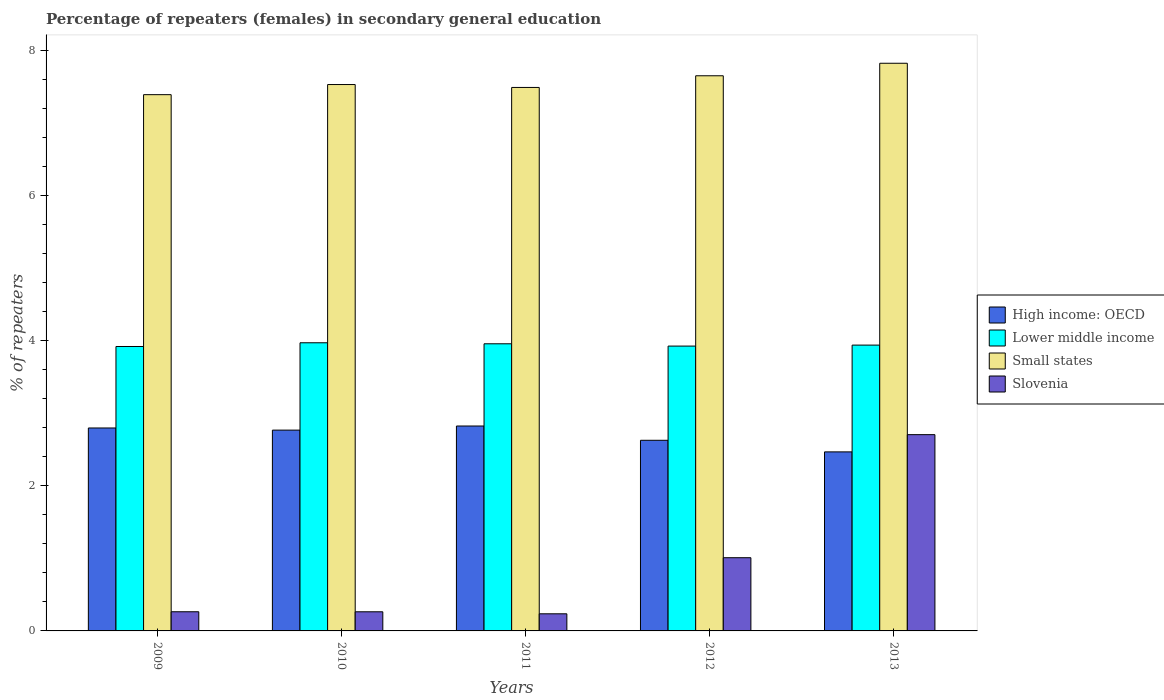How many different coloured bars are there?
Ensure brevity in your answer.  4. Are the number of bars per tick equal to the number of legend labels?
Ensure brevity in your answer.  Yes. How many bars are there on the 4th tick from the left?
Provide a succinct answer. 4. How many bars are there on the 2nd tick from the right?
Make the answer very short. 4. What is the label of the 5th group of bars from the left?
Your answer should be compact. 2013. In how many cases, is the number of bars for a given year not equal to the number of legend labels?
Ensure brevity in your answer.  0. What is the percentage of female repeaters in Small states in 2009?
Give a very brief answer. 7.39. Across all years, what is the maximum percentage of female repeaters in Slovenia?
Your response must be concise. 2.71. Across all years, what is the minimum percentage of female repeaters in Slovenia?
Give a very brief answer. 0.24. In which year was the percentage of female repeaters in High income: OECD maximum?
Keep it short and to the point. 2011. What is the total percentage of female repeaters in Slovenia in the graph?
Ensure brevity in your answer.  4.48. What is the difference between the percentage of female repeaters in Lower middle income in 2011 and that in 2012?
Provide a short and direct response. 0.03. What is the difference between the percentage of female repeaters in High income: OECD in 2011 and the percentage of female repeaters in Small states in 2009?
Your response must be concise. -4.57. What is the average percentage of female repeaters in Lower middle income per year?
Make the answer very short. 3.94. In the year 2011, what is the difference between the percentage of female repeaters in Slovenia and percentage of female repeaters in Lower middle income?
Your response must be concise. -3.72. What is the ratio of the percentage of female repeaters in Small states in 2009 to that in 2012?
Your answer should be very brief. 0.97. What is the difference between the highest and the second highest percentage of female repeaters in Slovenia?
Your response must be concise. 1.7. What is the difference between the highest and the lowest percentage of female repeaters in High income: OECD?
Your answer should be compact. 0.36. Is the sum of the percentage of female repeaters in Small states in 2011 and 2012 greater than the maximum percentage of female repeaters in Lower middle income across all years?
Make the answer very short. Yes. What does the 3rd bar from the left in 2013 represents?
Offer a very short reply. Small states. What does the 3rd bar from the right in 2013 represents?
Provide a succinct answer. Lower middle income. Is it the case that in every year, the sum of the percentage of female repeaters in High income: OECD and percentage of female repeaters in Slovenia is greater than the percentage of female repeaters in Lower middle income?
Give a very brief answer. No. How many bars are there?
Provide a succinct answer. 20. How many legend labels are there?
Ensure brevity in your answer.  4. What is the title of the graph?
Your answer should be very brief. Percentage of repeaters (females) in secondary general education. What is the label or title of the X-axis?
Give a very brief answer. Years. What is the label or title of the Y-axis?
Offer a terse response. % of repeaters. What is the % of repeaters in High income: OECD in 2009?
Keep it short and to the point. 2.8. What is the % of repeaters in Lower middle income in 2009?
Offer a terse response. 3.92. What is the % of repeaters of Small states in 2009?
Make the answer very short. 7.39. What is the % of repeaters in Slovenia in 2009?
Keep it short and to the point. 0.26. What is the % of repeaters of High income: OECD in 2010?
Offer a very short reply. 2.77. What is the % of repeaters in Lower middle income in 2010?
Provide a succinct answer. 3.97. What is the % of repeaters in Small states in 2010?
Provide a short and direct response. 7.53. What is the % of repeaters in Slovenia in 2010?
Provide a short and direct response. 0.26. What is the % of repeaters of High income: OECD in 2011?
Provide a short and direct response. 2.82. What is the % of repeaters of Lower middle income in 2011?
Offer a terse response. 3.96. What is the % of repeaters in Small states in 2011?
Make the answer very short. 7.49. What is the % of repeaters in Slovenia in 2011?
Offer a very short reply. 0.24. What is the % of repeaters of High income: OECD in 2012?
Your response must be concise. 2.63. What is the % of repeaters of Lower middle income in 2012?
Provide a succinct answer. 3.93. What is the % of repeaters of Small states in 2012?
Offer a very short reply. 7.65. What is the % of repeaters of Slovenia in 2012?
Your answer should be compact. 1.01. What is the % of repeaters in High income: OECD in 2013?
Provide a succinct answer. 2.47. What is the % of repeaters in Lower middle income in 2013?
Offer a very short reply. 3.94. What is the % of repeaters of Small states in 2013?
Your response must be concise. 7.83. What is the % of repeaters in Slovenia in 2013?
Your answer should be very brief. 2.71. Across all years, what is the maximum % of repeaters of High income: OECD?
Offer a terse response. 2.82. Across all years, what is the maximum % of repeaters in Lower middle income?
Offer a terse response. 3.97. Across all years, what is the maximum % of repeaters in Small states?
Your answer should be compact. 7.83. Across all years, what is the maximum % of repeaters in Slovenia?
Ensure brevity in your answer.  2.71. Across all years, what is the minimum % of repeaters in High income: OECD?
Your response must be concise. 2.47. Across all years, what is the minimum % of repeaters in Lower middle income?
Your answer should be very brief. 3.92. Across all years, what is the minimum % of repeaters in Small states?
Offer a terse response. 7.39. Across all years, what is the minimum % of repeaters in Slovenia?
Give a very brief answer. 0.24. What is the total % of repeaters in High income: OECD in the graph?
Provide a succinct answer. 13.49. What is the total % of repeaters in Lower middle income in the graph?
Your answer should be very brief. 19.72. What is the total % of repeaters of Small states in the graph?
Make the answer very short. 37.89. What is the total % of repeaters of Slovenia in the graph?
Offer a terse response. 4.48. What is the difference between the % of repeaters in High income: OECD in 2009 and that in 2010?
Your answer should be very brief. 0.03. What is the difference between the % of repeaters in Lower middle income in 2009 and that in 2010?
Offer a very short reply. -0.05. What is the difference between the % of repeaters of Small states in 2009 and that in 2010?
Make the answer very short. -0.14. What is the difference between the % of repeaters in High income: OECD in 2009 and that in 2011?
Your answer should be compact. -0.03. What is the difference between the % of repeaters of Lower middle income in 2009 and that in 2011?
Your answer should be compact. -0.04. What is the difference between the % of repeaters in Small states in 2009 and that in 2011?
Offer a very short reply. -0.1. What is the difference between the % of repeaters of Slovenia in 2009 and that in 2011?
Keep it short and to the point. 0.03. What is the difference between the % of repeaters of High income: OECD in 2009 and that in 2012?
Keep it short and to the point. 0.17. What is the difference between the % of repeaters in Lower middle income in 2009 and that in 2012?
Your response must be concise. -0.01. What is the difference between the % of repeaters in Small states in 2009 and that in 2012?
Make the answer very short. -0.26. What is the difference between the % of repeaters of Slovenia in 2009 and that in 2012?
Offer a terse response. -0.74. What is the difference between the % of repeaters in High income: OECD in 2009 and that in 2013?
Ensure brevity in your answer.  0.33. What is the difference between the % of repeaters in Lower middle income in 2009 and that in 2013?
Your answer should be very brief. -0.02. What is the difference between the % of repeaters of Small states in 2009 and that in 2013?
Give a very brief answer. -0.43. What is the difference between the % of repeaters in Slovenia in 2009 and that in 2013?
Your response must be concise. -2.44. What is the difference between the % of repeaters of High income: OECD in 2010 and that in 2011?
Provide a succinct answer. -0.06. What is the difference between the % of repeaters in Lower middle income in 2010 and that in 2011?
Offer a terse response. 0.01. What is the difference between the % of repeaters in Small states in 2010 and that in 2011?
Make the answer very short. 0.04. What is the difference between the % of repeaters of Slovenia in 2010 and that in 2011?
Provide a succinct answer. 0.03. What is the difference between the % of repeaters in High income: OECD in 2010 and that in 2012?
Your answer should be compact. 0.14. What is the difference between the % of repeaters of Lower middle income in 2010 and that in 2012?
Provide a short and direct response. 0.05. What is the difference between the % of repeaters in Small states in 2010 and that in 2012?
Provide a short and direct response. -0.12. What is the difference between the % of repeaters in Slovenia in 2010 and that in 2012?
Provide a short and direct response. -0.75. What is the difference between the % of repeaters of High income: OECD in 2010 and that in 2013?
Offer a very short reply. 0.3. What is the difference between the % of repeaters in Lower middle income in 2010 and that in 2013?
Make the answer very short. 0.03. What is the difference between the % of repeaters of Small states in 2010 and that in 2013?
Keep it short and to the point. -0.29. What is the difference between the % of repeaters in Slovenia in 2010 and that in 2013?
Offer a terse response. -2.44. What is the difference between the % of repeaters in High income: OECD in 2011 and that in 2012?
Keep it short and to the point. 0.2. What is the difference between the % of repeaters of Lower middle income in 2011 and that in 2012?
Provide a short and direct response. 0.03. What is the difference between the % of repeaters in Small states in 2011 and that in 2012?
Keep it short and to the point. -0.16. What is the difference between the % of repeaters in Slovenia in 2011 and that in 2012?
Offer a very short reply. -0.77. What is the difference between the % of repeaters of High income: OECD in 2011 and that in 2013?
Give a very brief answer. 0.36. What is the difference between the % of repeaters in Lower middle income in 2011 and that in 2013?
Keep it short and to the point. 0.02. What is the difference between the % of repeaters of Slovenia in 2011 and that in 2013?
Offer a terse response. -2.47. What is the difference between the % of repeaters in High income: OECD in 2012 and that in 2013?
Your response must be concise. 0.16. What is the difference between the % of repeaters of Lower middle income in 2012 and that in 2013?
Provide a succinct answer. -0.01. What is the difference between the % of repeaters in Small states in 2012 and that in 2013?
Your answer should be very brief. -0.17. What is the difference between the % of repeaters in Slovenia in 2012 and that in 2013?
Make the answer very short. -1.7. What is the difference between the % of repeaters of High income: OECD in 2009 and the % of repeaters of Lower middle income in 2010?
Provide a short and direct response. -1.17. What is the difference between the % of repeaters in High income: OECD in 2009 and the % of repeaters in Small states in 2010?
Ensure brevity in your answer.  -4.73. What is the difference between the % of repeaters of High income: OECD in 2009 and the % of repeaters of Slovenia in 2010?
Your response must be concise. 2.53. What is the difference between the % of repeaters of Lower middle income in 2009 and the % of repeaters of Small states in 2010?
Offer a terse response. -3.61. What is the difference between the % of repeaters in Lower middle income in 2009 and the % of repeaters in Slovenia in 2010?
Your response must be concise. 3.66. What is the difference between the % of repeaters in Small states in 2009 and the % of repeaters in Slovenia in 2010?
Your response must be concise. 7.13. What is the difference between the % of repeaters of High income: OECD in 2009 and the % of repeaters of Lower middle income in 2011?
Make the answer very short. -1.16. What is the difference between the % of repeaters of High income: OECD in 2009 and the % of repeaters of Small states in 2011?
Your response must be concise. -4.69. What is the difference between the % of repeaters of High income: OECD in 2009 and the % of repeaters of Slovenia in 2011?
Ensure brevity in your answer.  2.56. What is the difference between the % of repeaters of Lower middle income in 2009 and the % of repeaters of Small states in 2011?
Your response must be concise. -3.57. What is the difference between the % of repeaters of Lower middle income in 2009 and the % of repeaters of Slovenia in 2011?
Keep it short and to the point. 3.68. What is the difference between the % of repeaters in Small states in 2009 and the % of repeaters in Slovenia in 2011?
Ensure brevity in your answer.  7.16. What is the difference between the % of repeaters of High income: OECD in 2009 and the % of repeaters of Lower middle income in 2012?
Provide a short and direct response. -1.13. What is the difference between the % of repeaters in High income: OECD in 2009 and the % of repeaters in Small states in 2012?
Your answer should be very brief. -4.86. What is the difference between the % of repeaters of High income: OECD in 2009 and the % of repeaters of Slovenia in 2012?
Give a very brief answer. 1.79. What is the difference between the % of repeaters in Lower middle income in 2009 and the % of repeaters in Small states in 2012?
Give a very brief answer. -3.73. What is the difference between the % of repeaters of Lower middle income in 2009 and the % of repeaters of Slovenia in 2012?
Offer a terse response. 2.91. What is the difference between the % of repeaters in Small states in 2009 and the % of repeaters in Slovenia in 2012?
Give a very brief answer. 6.38. What is the difference between the % of repeaters of High income: OECD in 2009 and the % of repeaters of Lower middle income in 2013?
Ensure brevity in your answer.  -1.14. What is the difference between the % of repeaters in High income: OECD in 2009 and the % of repeaters in Small states in 2013?
Your response must be concise. -5.03. What is the difference between the % of repeaters of High income: OECD in 2009 and the % of repeaters of Slovenia in 2013?
Your answer should be very brief. 0.09. What is the difference between the % of repeaters of Lower middle income in 2009 and the % of repeaters of Small states in 2013?
Ensure brevity in your answer.  -3.9. What is the difference between the % of repeaters of Lower middle income in 2009 and the % of repeaters of Slovenia in 2013?
Provide a succinct answer. 1.22. What is the difference between the % of repeaters in Small states in 2009 and the % of repeaters in Slovenia in 2013?
Offer a very short reply. 4.69. What is the difference between the % of repeaters of High income: OECD in 2010 and the % of repeaters of Lower middle income in 2011?
Provide a succinct answer. -1.19. What is the difference between the % of repeaters in High income: OECD in 2010 and the % of repeaters in Small states in 2011?
Your response must be concise. -4.72. What is the difference between the % of repeaters in High income: OECD in 2010 and the % of repeaters in Slovenia in 2011?
Keep it short and to the point. 2.53. What is the difference between the % of repeaters in Lower middle income in 2010 and the % of repeaters in Small states in 2011?
Offer a terse response. -3.52. What is the difference between the % of repeaters of Lower middle income in 2010 and the % of repeaters of Slovenia in 2011?
Provide a succinct answer. 3.74. What is the difference between the % of repeaters of Small states in 2010 and the % of repeaters of Slovenia in 2011?
Your response must be concise. 7.3. What is the difference between the % of repeaters of High income: OECD in 2010 and the % of repeaters of Lower middle income in 2012?
Your answer should be compact. -1.16. What is the difference between the % of repeaters of High income: OECD in 2010 and the % of repeaters of Small states in 2012?
Make the answer very short. -4.88. What is the difference between the % of repeaters in High income: OECD in 2010 and the % of repeaters in Slovenia in 2012?
Offer a terse response. 1.76. What is the difference between the % of repeaters of Lower middle income in 2010 and the % of repeaters of Small states in 2012?
Give a very brief answer. -3.68. What is the difference between the % of repeaters of Lower middle income in 2010 and the % of repeaters of Slovenia in 2012?
Your answer should be very brief. 2.96. What is the difference between the % of repeaters of Small states in 2010 and the % of repeaters of Slovenia in 2012?
Offer a terse response. 6.52. What is the difference between the % of repeaters in High income: OECD in 2010 and the % of repeaters in Lower middle income in 2013?
Offer a very short reply. -1.17. What is the difference between the % of repeaters of High income: OECD in 2010 and the % of repeaters of Small states in 2013?
Your answer should be compact. -5.06. What is the difference between the % of repeaters in High income: OECD in 2010 and the % of repeaters in Slovenia in 2013?
Offer a very short reply. 0.06. What is the difference between the % of repeaters of Lower middle income in 2010 and the % of repeaters of Small states in 2013?
Provide a short and direct response. -3.85. What is the difference between the % of repeaters of Lower middle income in 2010 and the % of repeaters of Slovenia in 2013?
Offer a very short reply. 1.27. What is the difference between the % of repeaters in Small states in 2010 and the % of repeaters in Slovenia in 2013?
Give a very brief answer. 4.83. What is the difference between the % of repeaters of High income: OECD in 2011 and the % of repeaters of Lower middle income in 2012?
Your response must be concise. -1.1. What is the difference between the % of repeaters of High income: OECD in 2011 and the % of repeaters of Small states in 2012?
Give a very brief answer. -4.83. What is the difference between the % of repeaters of High income: OECD in 2011 and the % of repeaters of Slovenia in 2012?
Provide a short and direct response. 1.82. What is the difference between the % of repeaters in Lower middle income in 2011 and the % of repeaters in Small states in 2012?
Provide a short and direct response. -3.69. What is the difference between the % of repeaters of Lower middle income in 2011 and the % of repeaters of Slovenia in 2012?
Your answer should be very brief. 2.95. What is the difference between the % of repeaters in Small states in 2011 and the % of repeaters in Slovenia in 2012?
Make the answer very short. 6.48. What is the difference between the % of repeaters of High income: OECD in 2011 and the % of repeaters of Lower middle income in 2013?
Offer a terse response. -1.12. What is the difference between the % of repeaters of High income: OECD in 2011 and the % of repeaters of Small states in 2013?
Your answer should be very brief. -5. What is the difference between the % of repeaters in High income: OECD in 2011 and the % of repeaters in Slovenia in 2013?
Your answer should be very brief. 0.12. What is the difference between the % of repeaters of Lower middle income in 2011 and the % of repeaters of Small states in 2013?
Provide a short and direct response. -3.87. What is the difference between the % of repeaters in Lower middle income in 2011 and the % of repeaters in Slovenia in 2013?
Keep it short and to the point. 1.25. What is the difference between the % of repeaters of Small states in 2011 and the % of repeaters of Slovenia in 2013?
Provide a short and direct response. 4.79. What is the difference between the % of repeaters in High income: OECD in 2012 and the % of repeaters in Lower middle income in 2013?
Your answer should be very brief. -1.31. What is the difference between the % of repeaters in High income: OECD in 2012 and the % of repeaters in Small states in 2013?
Give a very brief answer. -5.2. What is the difference between the % of repeaters of High income: OECD in 2012 and the % of repeaters of Slovenia in 2013?
Offer a terse response. -0.08. What is the difference between the % of repeaters of Lower middle income in 2012 and the % of repeaters of Small states in 2013?
Your answer should be very brief. -3.9. What is the difference between the % of repeaters in Lower middle income in 2012 and the % of repeaters in Slovenia in 2013?
Keep it short and to the point. 1.22. What is the difference between the % of repeaters of Small states in 2012 and the % of repeaters of Slovenia in 2013?
Offer a very short reply. 4.95. What is the average % of repeaters of High income: OECD per year?
Give a very brief answer. 2.7. What is the average % of repeaters in Lower middle income per year?
Make the answer very short. 3.94. What is the average % of repeaters in Small states per year?
Offer a very short reply. 7.58. What is the average % of repeaters of Slovenia per year?
Provide a short and direct response. 0.9. In the year 2009, what is the difference between the % of repeaters in High income: OECD and % of repeaters in Lower middle income?
Your response must be concise. -1.12. In the year 2009, what is the difference between the % of repeaters in High income: OECD and % of repeaters in Small states?
Provide a short and direct response. -4.59. In the year 2009, what is the difference between the % of repeaters in High income: OECD and % of repeaters in Slovenia?
Your response must be concise. 2.53. In the year 2009, what is the difference between the % of repeaters of Lower middle income and % of repeaters of Small states?
Ensure brevity in your answer.  -3.47. In the year 2009, what is the difference between the % of repeaters of Lower middle income and % of repeaters of Slovenia?
Your answer should be very brief. 3.66. In the year 2009, what is the difference between the % of repeaters in Small states and % of repeaters in Slovenia?
Your answer should be very brief. 7.13. In the year 2010, what is the difference between the % of repeaters in High income: OECD and % of repeaters in Lower middle income?
Offer a very short reply. -1.2. In the year 2010, what is the difference between the % of repeaters in High income: OECD and % of repeaters in Small states?
Your answer should be very brief. -4.76. In the year 2010, what is the difference between the % of repeaters in High income: OECD and % of repeaters in Slovenia?
Provide a short and direct response. 2.5. In the year 2010, what is the difference between the % of repeaters of Lower middle income and % of repeaters of Small states?
Provide a short and direct response. -3.56. In the year 2010, what is the difference between the % of repeaters in Lower middle income and % of repeaters in Slovenia?
Ensure brevity in your answer.  3.71. In the year 2010, what is the difference between the % of repeaters in Small states and % of repeaters in Slovenia?
Ensure brevity in your answer.  7.27. In the year 2011, what is the difference between the % of repeaters of High income: OECD and % of repeaters of Lower middle income?
Offer a very short reply. -1.13. In the year 2011, what is the difference between the % of repeaters in High income: OECD and % of repeaters in Small states?
Ensure brevity in your answer.  -4.67. In the year 2011, what is the difference between the % of repeaters of High income: OECD and % of repeaters of Slovenia?
Offer a terse response. 2.59. In the year 2011, what is the difference between the % of repeaters in Lower middle income and % of repeaters in Small states?
Keep it short and to the point. -3.53. In the year 2011, what is the difference between the % of repeaters in Lower middle income and % of repeaters in Slovenia?
Your answer should be compact. 3.72. In the year 2011, what is the difference between the % of repeaters in Small states and % of repeaters in Slovenia?
Your answer should be compact. 7.26. In the year 2012, what is the difference between the % of repeaters of High income: OECD and % of repeaters of Lower middle income?
Make the answer very short. -1.3. In the year 2012, what is the difference between the % of repeaters of High income: OECD and % of repeaters of Small states?
Your answer should be compact. -5.03. In the year 2012, what is the difference between the % of repeaters of High income: OECD and % of repeaters of Slovenia?
Give a very brief answer. 1.62. In the year 2012, what is the difference between the % of repeaters in Lower middle income and % of repeaters in Small states?
Your response must be concise. -3.73. In the year 2012, what is the difference between the % of repeaters of Lower middle income and % of repeaters of Slovenia?
Your answer should be compact. 2.92. In the year 2012, what is the difference between the % of repeaters of Small states and % of repeaters of Slovenia?
Your answer should be compact. 6.64. In the year 2013, what is the difference between the % of repeaters of High income: OECD and % of repeaters of Lower middle income?
Provide a succinct answer. -1.47. In the year 2013, what is the difference between the % of repeaters in High income: OECD and % of repeaters in Small states?
Your answer should be very brief. -5.36. In the year 2013, what is the difference between the % of repeaters in High income: OECD and % of repeaters in Slovenia?
Your answer should be compact. -0.24. In the year 2013, what is the difference between the % of repeaters in Lower middle income and % of repeaters in Small states?
Your answer should be compact. -3.89. In the year 2013, what is the difference between the % of repeaters in Lower middle income and % of repeaters in Slovenia?
Offer a terse response. 1.23. In the year 2013, what is the difference between the % of repeaters in Small states and % of repeaters in Slovenia?
Your answer should be compact. 5.12. What is the ratio of the % of repeaters of High income: OECD in 2009 to that in 2010?
Your answer should be compact. 1.01. What is the ratio of the % of repeaters in Lower middle income in 2009 to that in 2010?
Offer a terse response. 0.99. What is the ratio of the % of repeaters of Small states in 2009 to that in 2010?
Make the answer very short. 0.98. What is the ratio of the % of repeaters in Lower middle income in 2009 to that in 2011?
Your response must be concise. 0.99. What is the ratio of the % of repeaters of Small states in 2009 to that in 2011?
Provide a short and direct response. 0.99. What is the ratio of the % of repeaters of Slovenia in 2009 to that in 2011?
Offer a very short reply. 1.12. What is the ratio of the % of repeaters in High income: OECD in 2009 to that in 2012?
Keep it short and to the point. 1.06. What is the ratio of the % of repeaters of Lower middle income in 2009 to that in 2012?
Make the answer very short. 1. What is the ratio of the % of repeaters of Small states in 2009 to that in 2012?
Your response must be concise. 0.97. What is the ratio of the % of repeaters in Slovenia in 2009 to that in 2012?
Offer a very short reply. 0.26. What is the ratio of the % of repeaters of High income: OECD in 2009 to that in 2013?
Keep it short and to the point. 1.13. What is the ratio of the % of repeaters of Lower middle income in 2009 to that in 2013?
Provide a short and direct response. 1. What is the ratio of the % of repeaters in Small states in 2009 to that in 2013?
Your response must be concise. 0.94. What is the ratio of the % of repeaters in Slovenia in 2009 to that in 2013?
Provide a short and direct response. 0.1. What is the ratio of the % of repeaters in Slovenia in 2010 to that in 2011?
Your response must be concise. 1.12. What is the ratio of the % of repeaters of High income: OECD in 2010 to that in 2012?
Provide a succinct answer. 1.05. What is the ratio of the % of repeaters in Lower middle income in 2010 to that in 2012?
Offer a terse response. 1.01. What is the ratio of the % of repeaters of Small states in 2010 to that in 2012?
Provide a succinct answer. 0.98. What is the ratio of the % of repeaters in Slovenia in 2010 to that in 2012?
Your answer should be very brief. 0.26. What is the ratio of the % of repeaters in High income: OECD in 2010 to that in 2013?
Provide a short and direct response. 1.12. What is the ratio of the % of repeaters of Lower middle income in 2010 to that in 2013?
Offer a very short reply. 1.01. What is the ratio of the % of repeaters in Small states in 2010 to that in 2013?
Offer a terse response. 0.96. What is the ratio of the % of repeaters in Slovenia in 2010 to that in 2013?
Offer a terse response. 0.1. What is the ratio of the % of repeaters of High income: OECD in 2011 to that in 2012?
Provide a short and direct response. 1.07. What is the ratio of the % of repeaters in Lower middle income in 2011 to that in 2012?
Your answer should be compact. 1.01. What is the ratio of the % of repeaters in Small states in 2011 to that in 2012?
Provide a succinct answer. 0.98. What is the ratio of the % of repeaters in Slovenia in 2011 to that in 2012?
Your answer should be very brief. 0.23. What is the ratio of the % of repeaters of High income: OECD in 2011 to that in 2013?
Your response must be concise. 1.14. What is the ratio of the % of repeaters of Small states in 2011 to that in 2013?
Provide a short and direct response. 0.96. What is the ratio of the % of repeaters in Slovenia in 2011 to that in 2013?
Your answer should be compact. 0.09. What is the ratio of the % of repeaters in High income: OECD in 2012 to that in 2013?
Your answer should be compact. 1.06. What is the ratio of the % of repeaters of Small states in 2012 to that in 2013?
Give a very brief answer. 0.98. What is the ratio of the % of repeaters in Slovenia in 2012 to that in 2013?
Your response must be concise. 0.37. What is the difference between the highest and the second highest % of repeaters in High income: OECD?
Your answer should be compact. 0.03. What is the difference between the highest and the second highest % of repeaters in Lower middle income?
Provide a short and direct response. 0.01. What is the difference between the highest and the second highest % of repeaters in Small states?
Your answer should be compact. 0.17. What is the difference between the highest and the second highest % of repeaters in Slovenia?
Offer a very short reply. 1.7. What is the difference between the highest and the lowest % of repeaters in High income: OECD?
Give a very brief answer. 0.36. What is the difference between the highest and the lowest % of repeaters in Lower middle income?
Make the answer very short. 0.05. What is the difference between the highest and the lowest % of repeaters of Small states?
Make the answer very short. 0.43. What is the difference between the highest and the lowest % of repeaters of Slovenia?
Your response must be concise. 2.47. 